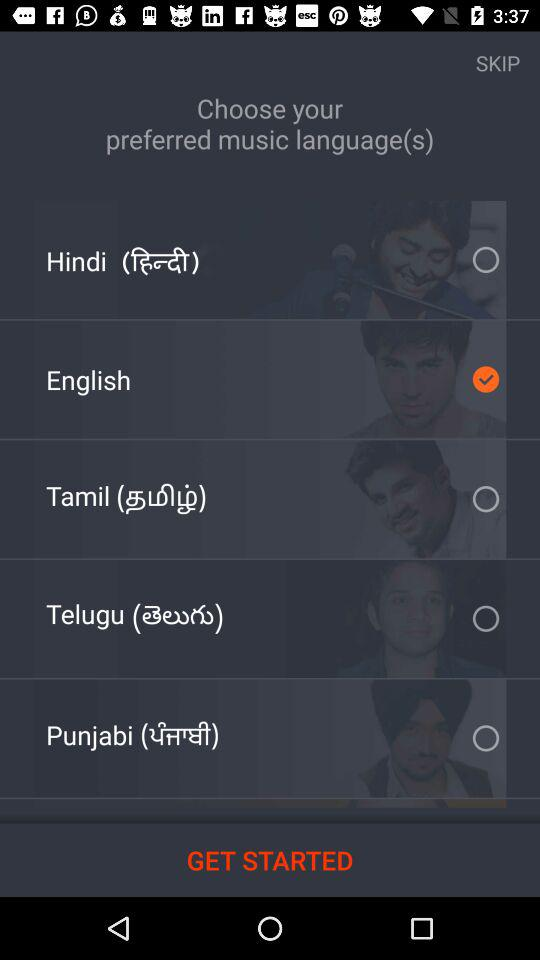How many languages are available to choose from?
Answer the question using a single word or phrase. 5 